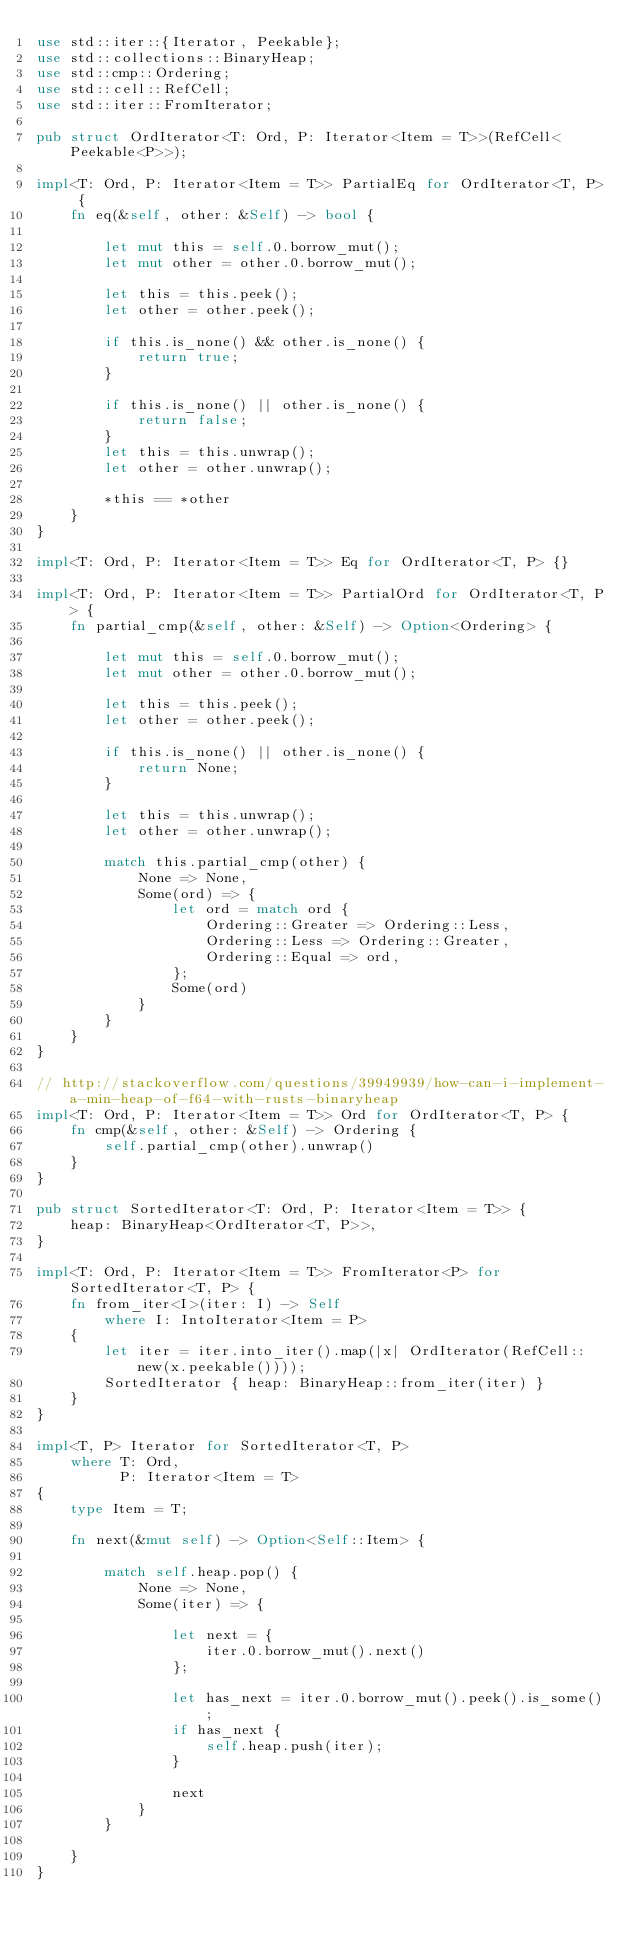Convert code to text. <code><loc_0><loc_0><loc_500><loc_500><_Rust_>use std::iter::{Iterator, Peekable};
use std::collections::BinaryHeap;
use std::cmp::Ordering;
use std::cell::RefCell;
use std::iter::FromIterator;

pub struct OrdIterator<T: Ord, P: Iterator<Item = T>>(RefCell<Peekable<P>>);

impl<T: Ord, P: Iterator<Item = T>> PartialEq for OrdIterator<T, P> {
    fn eq(&self, other: &Self) -> bool {

        let mut this = self.0.borrow_mut();
        let mut other = other.0.borrow_mut();

        let this = this.peek();
        let other = other.peek();

        if this.is_none() && other.is_none() {
            return true;
        }

        if this.is_none() || other.is_none() {
            return false;
        }
        let this = this.unwrap();
        let other = other.unwrap();

        *this == *other
    }
}

impl<T: Ord, P: Iterator<Item = T>> Eq for OrdIterator<T, P> {}

impl<T: Ord, P: Iterator<Item = T>> PartialOrd for OrdIterator<T, P> {
    fn partial_cmp(&self, other: &Self) -> Option<Ordering> {

        let mut this = self.0.borrow_mut();
        let mut other = other.0.borrow_mut();

        let this = this.peek();
        let other = other.peek();

        if this.is_none() || other.is_none() {
            return None;
        }

        let this = this.unwrap();
        let other = other.unwrap();

        match this.partial_cmp(other) {
            None => None,
            Some(ord) => {
                let ord = match ord {
                    Ordering::Greater => Ordering::Less,
                    Ordering::Less => Ordering::Greater,
                    Ordering::Equal => ord,
                };
                Some(ord)
            }
        }
    }
}

// http://stackoverflow.com/questions/39949939/how-can-i-implement-a-min-heap-of-f64-with-rusts-binaryheap
impl<T: Ord, P: Iterator<Item = T>> Ord for OrdIterator<T, P> {
    fn cmp(&self, other: &Self) -> Ordering {
        self.partial_cmp(other).unwrap()
    }
}

pub struct SortedIterator<T: Ord, P: Iterator<Item = T>> {
    heap: BinaryHeap<OrdIterator<T, P>>,
}

impl<T: Ord, P: Iterator<Item = T>> FromIterator<P> for SortedIterator<T, P> {
    fn from_iter<I>(iter: I) -> Self
        where I: IntoIterator<Item = P>
    {
        let iter = iter.into_iter().map(|x| OrdIterator(RefCell::new(x.peekable())));
        SortedIterator { heap: BinaryHeap::from_iter(iter) }
    }
}

impl<T, P> Iterator for SortedIterator<T, P>
    where T: Ord,
          P: Iterator<Item = T>
{
    type Item = T;

    fn next(&mut self) -> Option<Self::Item> {

        match self.heap.pop() {
            None => None,
            Some(iter) => {

                let next = {
                    iter.0.borrow_mut().next()
                };

                let has_next = iter.0.borrow_mut().peek().is_some();
                if has_next {
                    self.heap.push(iter);
                }

                next
            }
        }

    }
}
</code> 